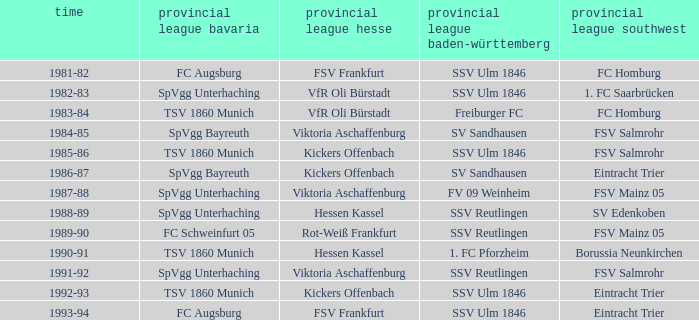Which Oberliga Baden-Württemberg has an Oberliga Hessen of fsv frankfurt in 1993-94? SSV Ulm 1846. 